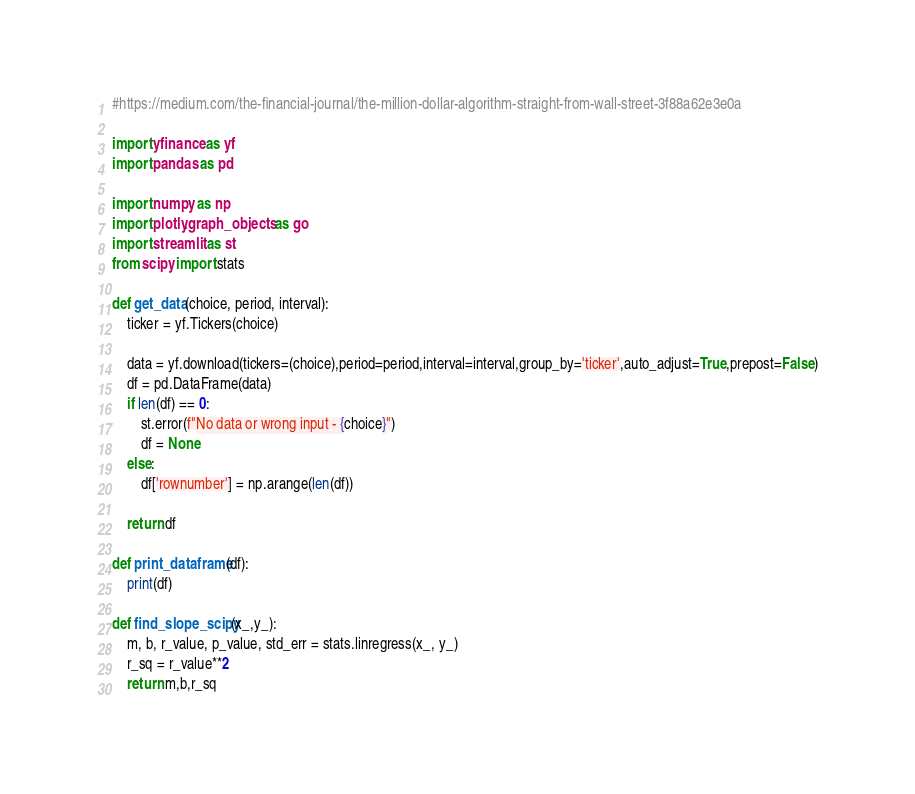<code> <loc_0><loc_0><loc_500><loc_500><_Python_>#https://medium.com/the-financial-journal/the-million-dollar-algorithm-straight-from-wall-street-3f88a62e3e0a

import yfinance as yf
import pandas as pd

import numpy as np
import plotly.graph_objects as go
import streamlit as st
from scipy import stats

def get_data(choice, period, interval):
    ticker = yf.Tickers(choice)

    data = yf.download(tickers=(choice),period=period,interval=interval,group_by='ticker',auto_adjust=True,prepost=False)
    df = pd.DataFrame(data)
    if len(df) == 0:
        st.error(f"No data or wrong input - {choice}")
        df = None
    else:
        df['rownumber'] = np.arange(len(df))

    return df

def print_dataframe(df):
    print(df)

def find_slope_scipy(x_,y_):
    m, b, r_value, p_value, std_err = stats.linregress(x_, y_)
    r_sq = r_value**2
    return m,b,r_sq
</code> 